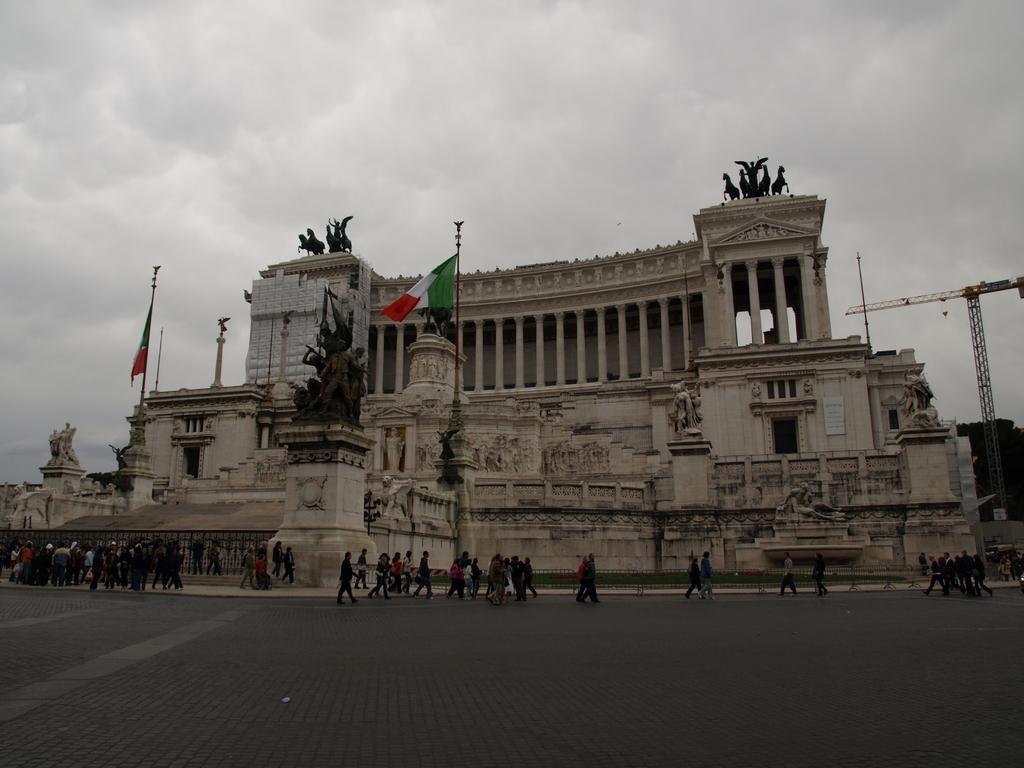How would you summarize this image in a sentence or two? In the center of the image, we can see statues and flags on the building and in the background, we can see people walking. At the bottom, there is road and at the top, there is sky. 